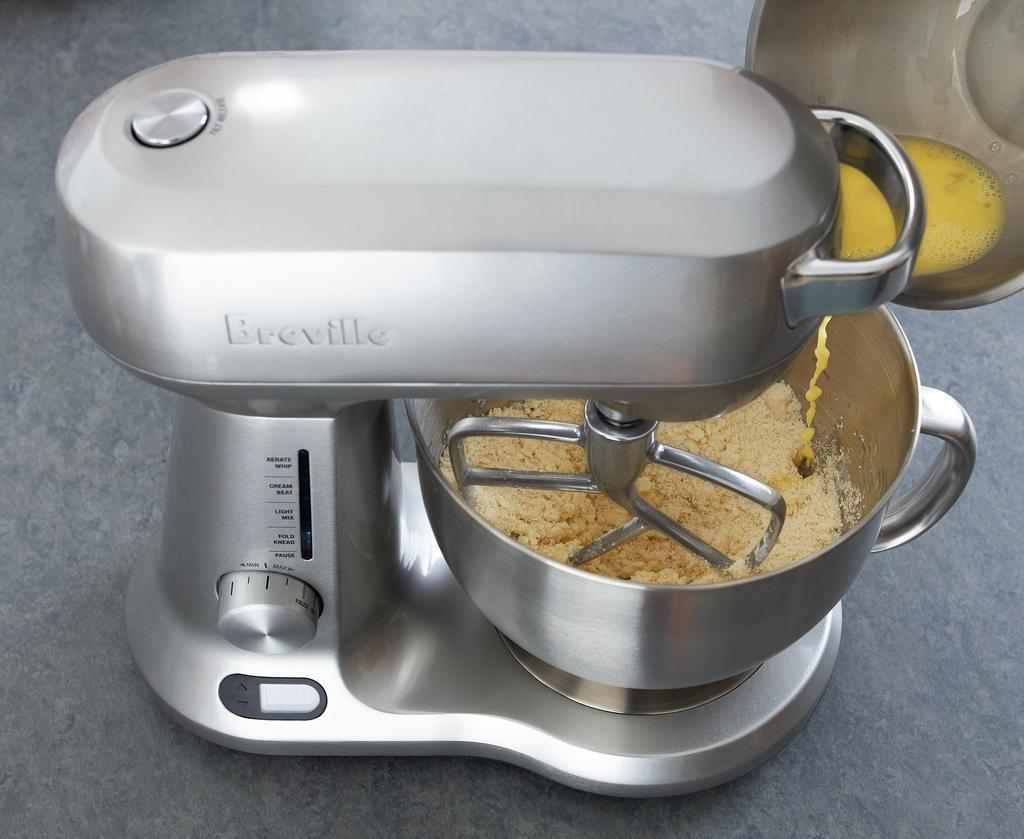<image>
Share a concise interpretation of the image provided. The Breville mixer has dry ingredients in it. 